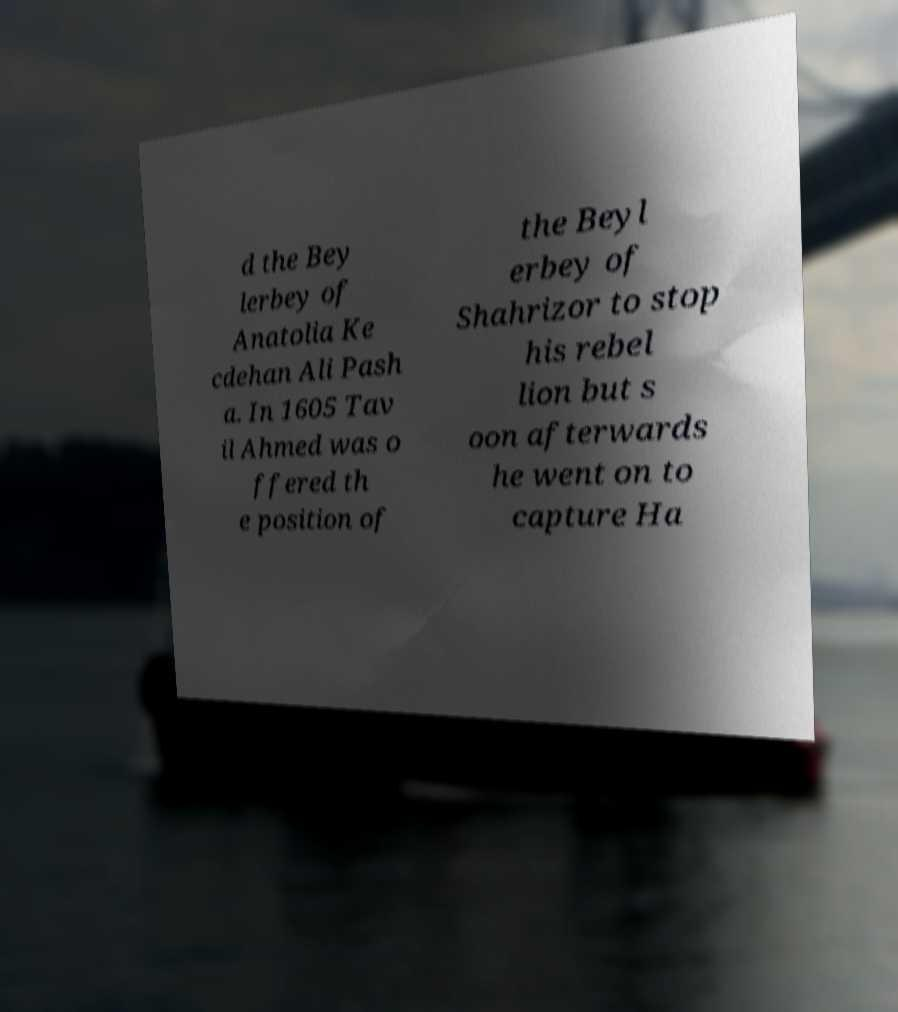Please read and relay the text visible in this image. What does it say? d the Bey lerbey of Anatolia Ke cdehan Ali Pash a. In 1605 Tav il Ahmed was o ffered th e position of the Beyl erbey of Shahrizor to stop his rebel lion but s oon afterwards he went on to capture Ha 